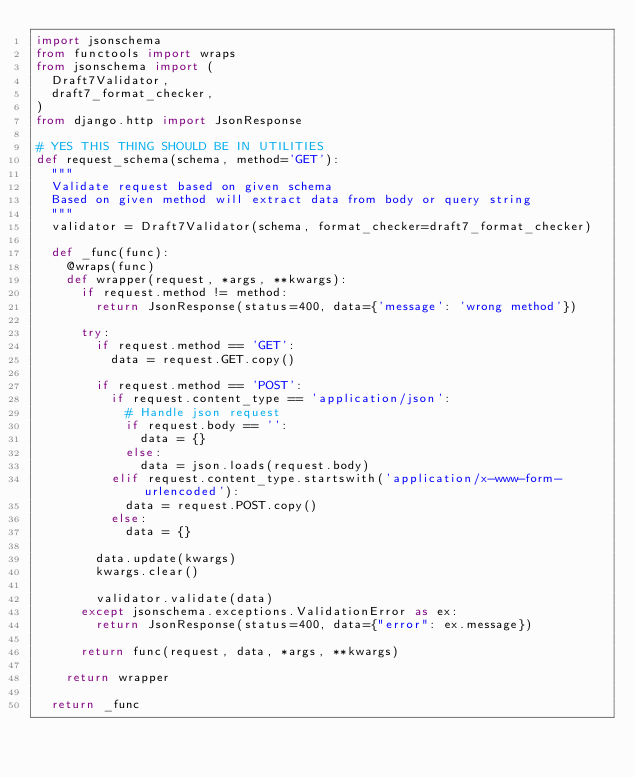Convert code to text. <code><loc_0><loc_0><loc_500><loc_500><_Python_>import jsonschema
from functools import wraps
from jsonschema import (
  Draft7Validator,
  draft7_format_checker,
)
from django.http import JsonResponse

# YES THIS THING SHOULD BE IN UTILITIES
def request_schema(schema, method='GET'):
  """
  Validate request based on given schema
  Based on given method will extract data from body or query string
  """
  validator = Draft7Validator(schema, format_checker=draft7_format_checker)

  def _func(func):
    @wraps(func)
    def wrapper(request, *args, **kwargs):
      if request.method != method:
        return JsonResponse(status=400, data={'message': 'wrong method'})
      
      try:
        if request.method == 'GET':
          data = request.GET.copy()
        
        if request.method == 'POST':
          if request.content_type == 'application/json':
            # Handle json request
            if request.body == '':
              data = {}
            else:
              data = json.loads(request.body)
          elif request.content_type.startswith('application/x-www-form-urlencoded'):
            data = request.POST.copy()
          else:
            data = {}

        data.update(kwargs)
        kwargs.clear()
        
        validator.validate(data)
      except jsonschema.exceptions.ValidationError as ex:
        return JsonResponse(status=400, data={"error": ex.message})

      return func(request, data, *args, **kwargs)

    return wrapper

  return _func
</code> 